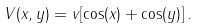Convert formula to latex. <formula><loc_0><loc_0><loc_500><loc_500>V ( x , y ) = v [ \cos ( x ) + \cos ( y ) ] \, .</formula> 